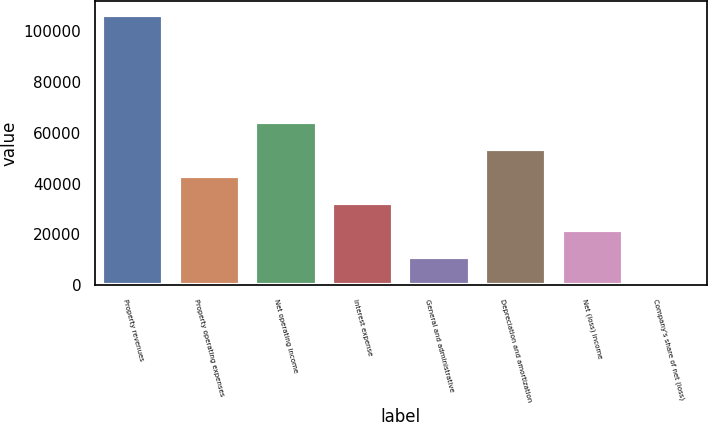Convert chart. <chart><loc_0><loc_0><loc_500><loc_500><bar_chart><fcel>Property revenues<fcel>Property operating expenses<fcel>Net operating income<fcel>Interest expense<fcel>General and administrative<fcel>Depreciation and amortization<fcel>Net (loss) income<fcel>Company's share of net (loss)<nl><fcel>106386<fcel>43066<fcel>64249.8<fcel>32242.7<fcel>11058.9<fcel>53657.9<fcel>21650.8<fcel>467<nl></chart> 